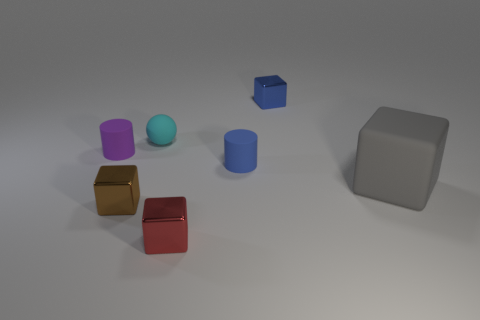Subtract all brown metal cubes. How many cubes are left? 3 Subtract all purple cylinders. How many cylinders are left? 1 Add 1 blue rubber blocks. How many objects exist? 8 Subtract all cylinders. How many objects are left? 5 Subtract 0 brown cylinders. How many objects are left? 7 Subtract 2 cylinders. How many cylinders are left? 0 Subtract all brown blocks. Subtract all cyan cylinders. How many blocks are left? 3 Subtract all small purple matte things. Subtract all big matte things. How many objects are left? 5 Add 4 gray blocks. How many gray blocks are left? 5 Add 6 brown cylinders. How many brown cylinders exist? 6 